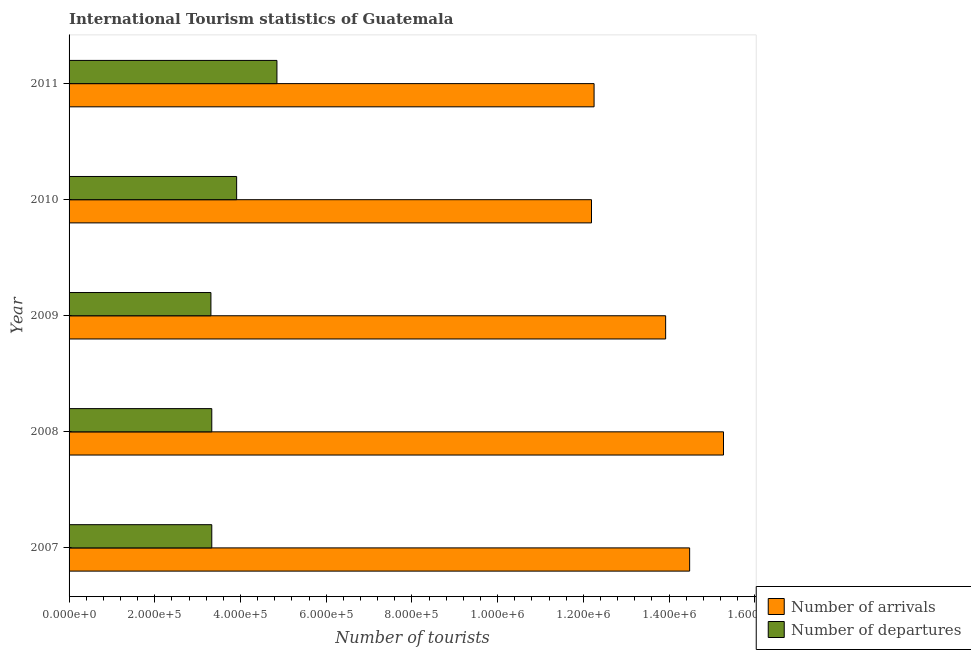How many different coloured bars are there?
Keep it short and to the point. 2. Are the number of bars per tick equal to the number of legend labels?
Your answer should be very brief. Yes. How many bars are there on the 3rd tick from the top?
Offer a terse response. 2. How many bars are there on the 3rd tick from the bottom?
Your answer should be very brief. 2. In how many cases, is the number of bars for a given year not equal to the number of legend labels?
Give a very brief answer. 0. What is the number of tourist departures in 2007?
Give a very brief answer. 3.33e+05. Across all years, what is the maximum number of tourist arrivals?
Make the answer very short. 1.53e+06. Across all years, what is the minimum number of tourist arrivals?
Your answer should be very brief. 1.22e+06. What is the total number of tourist departures in the graph?
Your response must be concise. 1.87e+06. What is the difference between the number of tourist arrivals in 2009 and that in 2010?
Your response must be concise. 1.73e+05. What is the difference between the number of tourist arrivals in 2010 and the number of tourist departures in 2011?
Your response must be concise. 7.34e+05. What is the average number of tourist departures per year?
Keep it short and to the point. 3.75e+05. In the year 2007, what is the difference between the number of tourist departures and number of tourist arrivals?
Your answer should be very brief. -1.12e+06. What is the ratio of the number of tourist arrivals in 2008 to that in 2011?
Give a very brief answer. 1.25. Is the difference between the number of tourist arrivals in 2008 and 2009 greater than the difference between the number of tourist departures in 2008 and 2009?
Offer a terse response. Yes. What is the difference between the highest and the second highest number of tourist departures?
Your response must be concise. 9.40e+04. What is the difference between the highest and the lowest number of tourist departures?
Your answer should be very brief. 1.54e+05. In how many years, is the number of tourist arrivals greater than the average number of tourist arrivals taken over all years?
Your answer should be very brief. 3. What does the 2nd bar from the top in 2007 represents?
Provide a short and direct response. Number of arrivals. What does the 1st bar from the bottom in 2007 represents?
Give a very brief answer. Number of arrivals. How many bars are there?
Offer a terse response. 10. How many years are there in the graph?
Give a very brief answer. 5. Are the values on the major ticks of X-axis written in scientific E-notation?
Give a very brief answer. Yes. Does the graph contain any zero values?
Your answer should be very brief. No. How are the legend labels stacked?
Offer a terse response. Vertical. What is the title of the graph?
Your answer should be compact. International Tourism statistics of Guatemala. Does "Taxes" appear as one of the legend labels in the graph?
Offer a very short reply. No. What is the label or title of the X-axis?
Your answer should be very brief. Number of tourists. What is the Number of tourists in Number of arrivals in 2007?
Your answer should be very brief. 1.45e+06. What is the Number of tourists of Number of departures in 2007?
Your answer should be compact. 3.33e+05. What is the Number of tourists in Number of arrivals in 2008?
Make the answer very short. 1.53e+06. What is the Number of tourists of Number of departures in 2008?
Offer a very short reply. 3.33e+05. What is the Number of tourists of Number of arrivals in 2009?
Offer a terse response. 1.39e+06. What is the Number of tourists of Number of departures in 2009?
Offer a terse response. 3.31e+05. What is the Number of tourists of Number of arrivals in 2010?
Keep it short and to the point. 1.22e+06. What is the Number of tourists in Number of departures in 2010?
Ensure brevity in your answer.  3.91e+05. What is the Number of tourists of Number of arrivals in 2011?
Provide a short and direct response. 1.22e+06. What is the Number of tourists in Number of departures in 2011?
Your response must be concise. 4.85e+05. Across all years, what is the maximum Number of tourists in Number of arrivals?
Keep it short and to the point. 1.53e+06. Across all years, what is the maximum Number of tourists in Number of departures?
Your answer should be very brief. 4.85e+05. Across all years, what is the minimum Number of tourists of Number of arrivals?
Your answer should be compact. 1.22e+06. Across all years, what is the minimum Number of tourists in Number of departures?
Your answer should be very brief. 3.31e+05. What is the total Number of tourists of Number of arrivals in the graph?
Keep it short and to the point. 6.81e+06. What is the total Number of tourists of Number of departures in the graph?
Provide a short and direct response. 1.87e+06. What is the difference between the Number of tourists of Number of arrivals in 2007 and that in 2008?
Provide a short and direct response. -7.90e+04. What is the difference between the Number of tourists in Number of departures in 2007 and that in 2008?
Provide a succinct answer. 0. What is the difference between the Number of tourists of Number of arrivals in 2007 and that in 2009?
Your answer should be compact. 5.60e+04. What is the difference between the Number of tourists of Number of arrivals in 2007 and that in 2010?
Give a very brief answer. 2.29e+05. What is the difference between the Number of tourists in Number of departures in 2007 and that in 2010?
Give a very brief answer. -5.80e+04. What is the difference between the Number of tourists in Number of arrivals in 2007 and that in 2011?
Offer a terse response. 2.23e+05. What is the difference between the Number of tourists of Number of departures in 2007 and that in 2011?
Keep it short and to the point. -1.52e+05. What is the difference between the Number of tourists of Number of arrivals in 2008 and that in 2009?
Give a very brief answer. 1.35e+05. What is the difference between the Number of tourists in Number of arrivals in 2008 and that in 2010?
Your answer should be compact. 3.08e+05. What is the difference between the Number of tourists in Number of departures in 2008 and that in 2010?
Make the answer very short. -5.80e+04. What is the difference between the Number of tourists of Number of arrivals in 2008 and that in 2011?
Keep it short and to the point. 3.02e+05. What is the difference between the Number of tourists of Number of departures in 2008 and that in 2011?
Make the answer very short. -1.52e+05. What is the difference between the Number of tourists of Number of arrivals in 2009 and that in 2010?
Offer a terse response. 1.73e+05. What is the difference between the Number of tourists in Number of departures in 2009 and that in 2010?
Your response must be concise. -6.00e+04. What is the difference between the Number of tourists in Number of arrivals in 2009 and that in 2011?
Your answer should be very brief. 1.67e+05. What is the difference between the Number of tourists in Number of departures in 2009 and that in 2011?
Provide a short and direct response. -1.54e+05. What is the difference between the Number of tourists in Number of arrivals in 2010 and that in 2011?
Offer a very short reply. -6000. What is the difference between the Number of tourists in Number of departures in 2010 and that in 2011?
Provide a succinct answer. -9.40e+04. What is the difference between the Number of tourists in Number of arrivals in 2007 and the Number of tourists in Number of departures in 2008?
Provide a succinct answer. 1.12e+06. What is the difference between the Number of tourists in Number of arrivals in 2007 and the Number of tourists in Number of departures in 2009?
Keep it short and to the point. 1.12e+06. What is the difference between the Number of tourists in Number of arrivals in 2007 and the Number of tourists in Number of departures in 2010?
Keep it short and to the point. 1.06e+06. What is the difference between the Number of tourists in Number of arrivals in 2007 and the Number of tourists in Number of departures in 2011?
Make the answer very short. 9.63e+05. What is the difference between the Number of tourists in Number of arrivals in 2008 and the Number of tourists in Number of departures in 2009?
Offer a terse response. 1.20e+06. What is the difference between the Number of tourists in Number of arrivals in 2008 and the Number of tourists in Number of departures in 2010?
Keep it short and to the point. 1.14e+06. What is the difference between the Number of tourists in Number of arrivals in 2008 and the Number of tourists in Number of departures in 2011?
Provide a succinct answer. 1.04e+06. What is the difference between the Number of tourists in Number of arrivals in 2009 and the Number of tourists in Number of departures in 2010?
Your response must be concise. 1.00e+06. What is the difference between the Number of tourists of Number of arrivals in 2009 and the Number of tourists of Number of departures in 2011?
Your response must be concise. 9.07e+05. What is the difference between the Number of tourists in Number of arrivals in 2010 and the Number of tourists in Number of departures in 2011?
Your answer should be compact. 7.34e+05. What is the average Number of tourists of Number of arrivals per year?
Offer a terse response. 1.36e+06. What is the average Number of tourists in Number of departures per year?
Give a very brief answer. 3.75e+05. In the year 2007, what is the difference between the Number of tourists of Number of arrivals and Number of tourists of Number of departures?
Provide a short and direct response. 1.12e+06. In the year 2008, what is the difference between the Number of tourists in Number of arrivals and Number of tourists in Number of departures?
Ensure brevity in your answer.  1.19e+06. In the year 2009, what is the difference between the Number of tourists in Number of arrivals and Number of tourists in Number of departures?
Provide a succinct answer. 1.06e+06. In the year 2010, what is the difference between the Number of tourists of Number of arrivals and Number of tourists of Number of departures?
Offer a very short reply. 8.28e+05. In the year 2011, what is the difference between the Number of tourists of Number of arrivals and Number of tourists of Number of departures?
Give a very brief answer. 7.40e+05. What is the ratio of the Number of tourists in Number of arrivals in 2007 to that in 2008?
Offer a very short reply. 0.95. What is the ratio of the Number of tourists of Number of departures in 2007 to that in 2008?
Offer a terse response. 1. What is the ratio of the Number of tourists in Number of arrivals in 2007 to that in 2009?
Your answer should be compact. 1.04. What is the ratio of the Number of tourists of Number of arrivals in 2007 to that in 2010?
Ensure brevity in your answer.  1.19. What is the ratio of the Number of tourists in Number of departures in 2007 to that in 2010?
Give a very brief answer. 0.85. What is the ratio of the Number of tourists of Number of arrivals in 2007 to that in 2011?
Give a very brief answer. 1.18. What is the ratio of the Number of tourists in Number of departures in 2007 to that in 2011?
Your answer should be compact. 0.69. What is the ratio of the Number of tourists of Number of arrivals in 2008 to that in 2009?
Ensure brevity in your answer.  1.1. What is the ratio of the Number of tourists of Number of departures in 2008 to that in 2009?
Ensure brevity in your answer.  1.01. What is the ratio of the Number of tourists in Number of arrivals in 2008 to that in 2010?
Ensure brevity in your answer.  1.25. What is the ratio of the Number of tourists in Number of departures in 2008 to that in 2010?
Provide a succinct answer. 0.85. What is the ratio of the Number of tourists in Number of arrivals in 2008 to that in 2011?
Provide a short and direct response. 1.25. What is the ratio of the Number of tourists in Number of departures in 2008 to that in 2011?
Your answer should be very brief. 0.69. What is the ratio of the Number of tourists in Number of arrivals in 2009 to that in 2010?
Your answer should be compact. 1.14. What is the ratio of the Number of tourists of Number of departures in 2009 to that in 2010?
Your response must be concise. 0.85. What is the ratio of the Number of tourists in Number of arrivals in 2009 to that in 2011?
Offer a terse response. 1.14. What is the ratio of the Number of tourists in Number of departures in 2009 to that in 2011?
Your answer should be very brief. 0.68. What is the ratio of the Number of tourists of Number of arrivals in 2010 to that in 2011?
Offer a terse response. 1. What is the ratio of the Number of tourists of Number of departures in 2010 to that in 2011?
Offer a terse response. 0.81. What is the difference between the highest and the second highest Number of tourists in Number of arrivals?
Keep it short and to the point. 7.90e+04. What is the difference between the highest and the second highest Number of tourists in Number of departures?
Offer a very short reply. 9.40e+04. What is the difference between the highest and the lowest Number of tourists in Number of arrivals?
Provide a short and direct response. 3.08e+05. What is the difference between the highest and the lowest Number of tourists of Number of departures?
Offer a very short reply. 1.54e+05. 